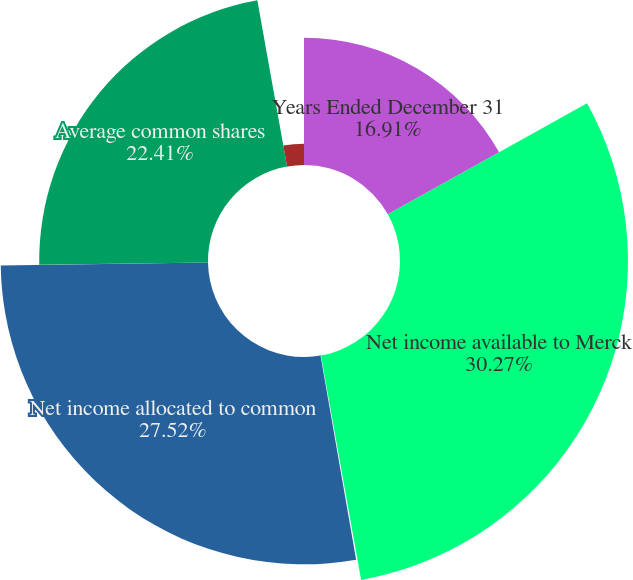<chart> <loc_0><loc_0><loc_500><loc_500><pie_chart><fcel>Years Ended December 31<fcel>Net income available to Merck<fcel>Less Income allocated to<fcel>Net income allocated to common<fcel>Average common shares<fcel>Common shares issuable (1)<nl><fcel>16.91%<fcel>30.27%<fcel>0.07%<fcel>27.52%<fcel>22.41%<fcel>2.82%<nl></chart> 